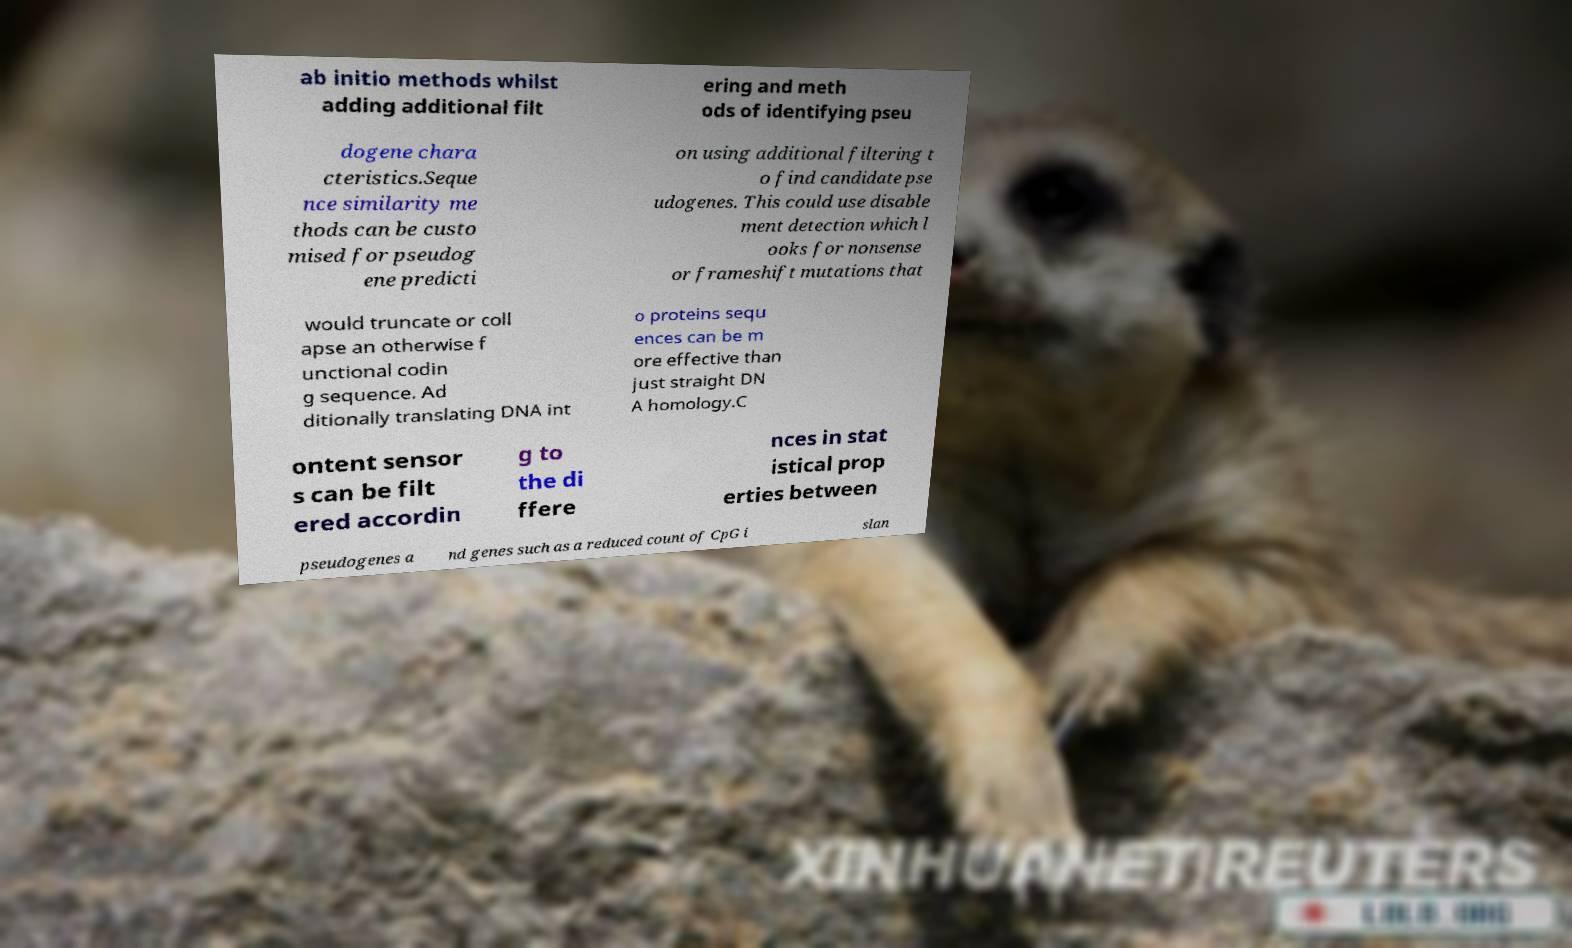Please read and relay the text visible in this image. What does it say? ab initio methods whilst adding additional filt ering and meth ods of identifying pseu dogene chara cteristics.Seque nce similarity me thods can be custo mised for pseudog ene predicti on using additional filtering t o find candidate pse udogenes. This could use disable ment detection which l ooks for nonsense or frameshift mutations that would truncate or coll apse an otherwise f unctional codin g sequence. Ad ditionally translating DNA int o proteins sequ ences can be m ore effective than just straight DN A homology.C ontent sensor s can be filt ered accordin g to the di ffere nces in stat istical prop erties between pseudogenes a nd genes such as a reduced count of CpG i slan 